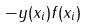<formula> <loc_0><loc_0><loc_500><loc_500>- y ( x _ { i } ) f ( x _ { i } )</formula> 